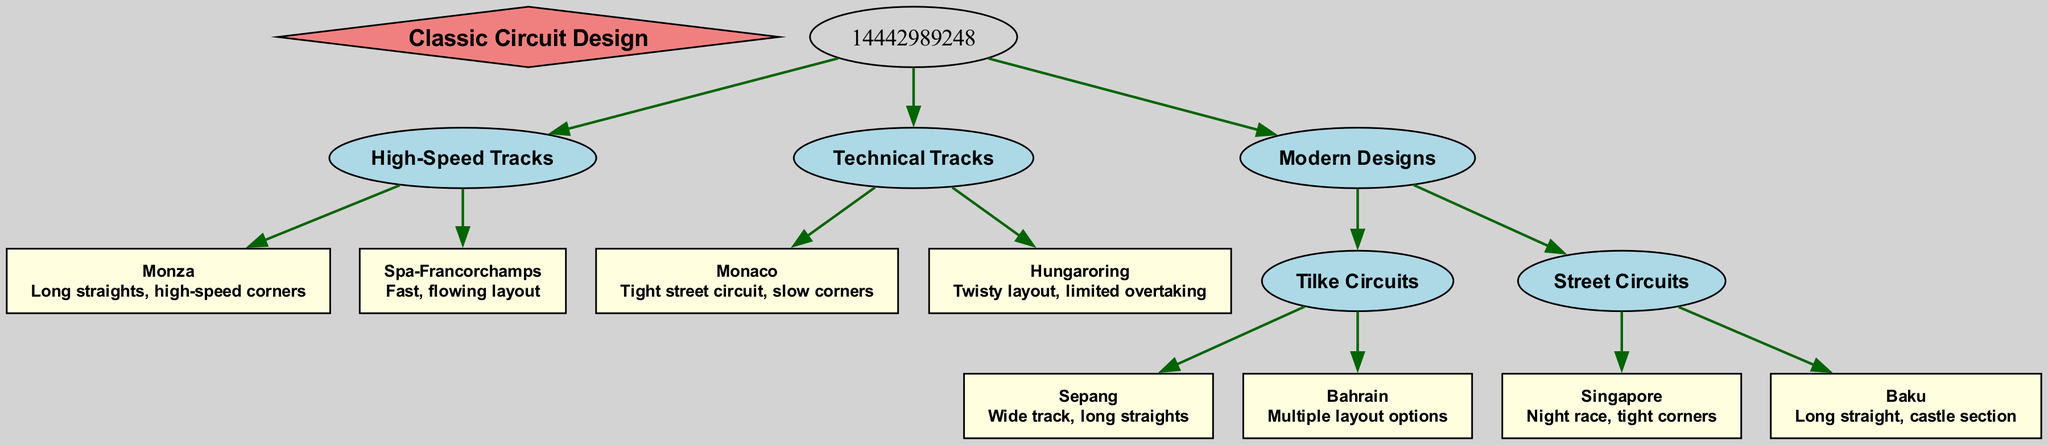What is the root of the family tree? The root node is defined in the data as "Classic Circuit Design." Therefore, tracing back to the initial point of the diagram leads to this answer.
Answer: Classic Circuit Design How many main categories are under the root? The root has three children categories: High-Speed Tracks, Technical Tracks, and Modern Designs. Counting these children provides the answer.
Answer: 3 Which circuit is an example of a high-speed track? Looking under the "High-Speed Tracks" category, "Monza" is listed as a circuit characterized by long straights and high-speed corners. This direct child of High-Speed Tracks provides the answer.
Answer: Monza What features describe the Monaco circuit? The "Monaco" node under "Technical Tracks" specifically includes features described as "Tight street circuit, slow corners." Therefore, looking at the features associated with this node provides the answer.
Answer: Tight street circuit, slow corners How many circuits are categorized as "Tilke Circuits"? The "Modern Designs" category contains a child named "Tilke Circuits," which in turn has two children: Sepang and Bahrain. Counting these children gives the total.
Answer: 2 Which circuit is known for its night race? Within the "Street Circuits" category under "Modern Designs," "Singapore" is mentioned as the circuit that hosts a night race, allowing for a straightforward identification based on specific features.
Answer: Singapore What type of layout does the Hungaroring have? Under the "Technical Tracks" category, the Hungaroring is explicitly described as having a "Twisty layout, limited overtaking." Identifying the features of this specific circuit leads directly to the answer.
Answer: Twisty layout, limited overtaking Which two tracks are included in the “Street Circuits” category? Exploring the “Street Circuits” category, we find two children: "Singapore" and "Baku." Listing these two specifies the answer.
Answer: Singapore, Baku What is the main feature of the Sepang circuit? The node for Sepang under "Tilke Circuits" describes the circuit as having a "Wide track, long straights." This identification from the features associated with the node yields the answer.
Answer: Wide track, long straights 